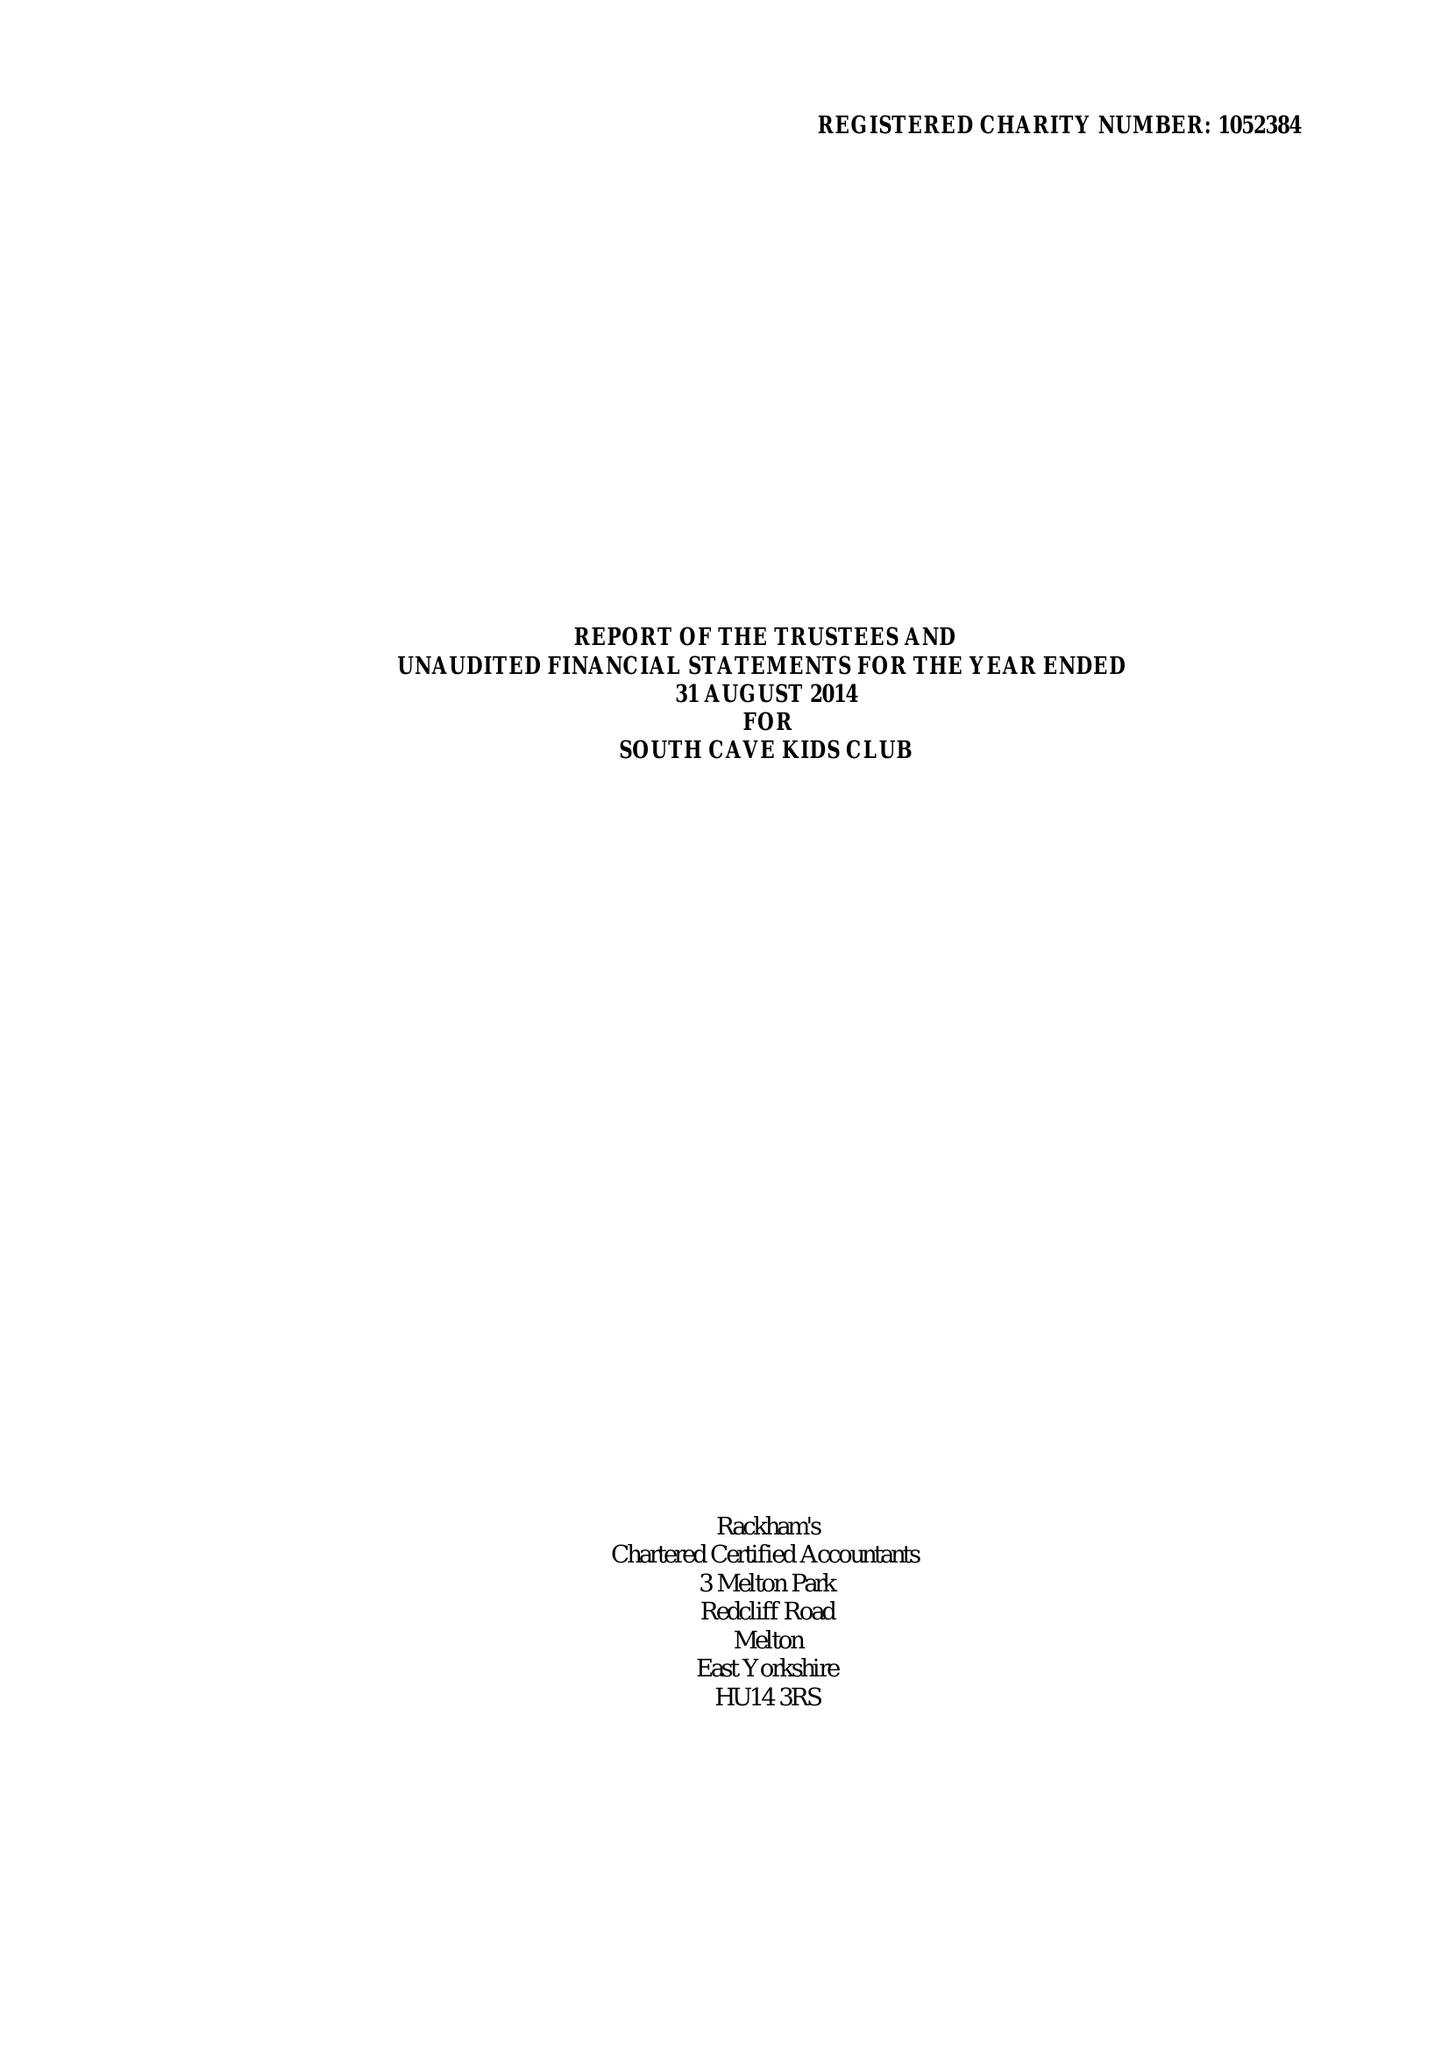What is the value for the spending_annually_in_british_pounds?
Answer the question using a single word or phrase. 82824.00 